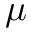Convert formula to latex. <formula><loc_0><loc_0><loc_500><loc_500>\mu</formula> 